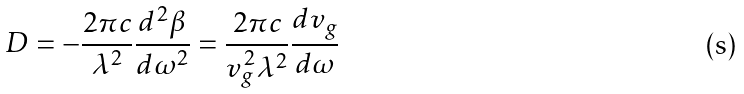<formula> <loc_0><loc_0><loc_500><loc_500>D = - { \frac { 2 \pi c } { \lambda ^ { 2 } } } { \frac { d ^ { 2 } \beta } { d \omega ^ { 2 } } } = { \frac { 2 \pi c } { v _ { g } ^ { 2 } \lambda ^ { 2 } } } { \frac { d v _ { g } } { d \omega } }</formula> 